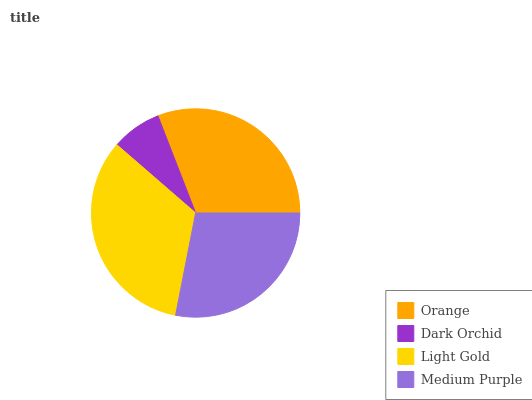Is Dark Orchid the minimum?
Answer yes or no. Yes. Is Light Gold the maximum?
Answer yes or no. Yes. Is Light Gold the minimum?
Answer yes or no. No. Is Dark Orchid the maximum?
Answer yes or no. No. Is Light Gold greater than Dark Orchid?
Answer yes or no. Yes. Is Dark Orchid less than Light Gold?
Answer yes or no. Yes. Is Dark Orchid greater than Light Gold?
Answer yes or no. No. Is Light Gold less than Dark Orchid?
Answer yes or no. No. Is Orange the high median?
Answer yes or no. Yes. Is Medium Purple the low median?
Answer yes or no. Yes. Is Light Gold the high median?
Answer yes or no. No. Is Light Gold the low median?
Answer yes or no. No. 